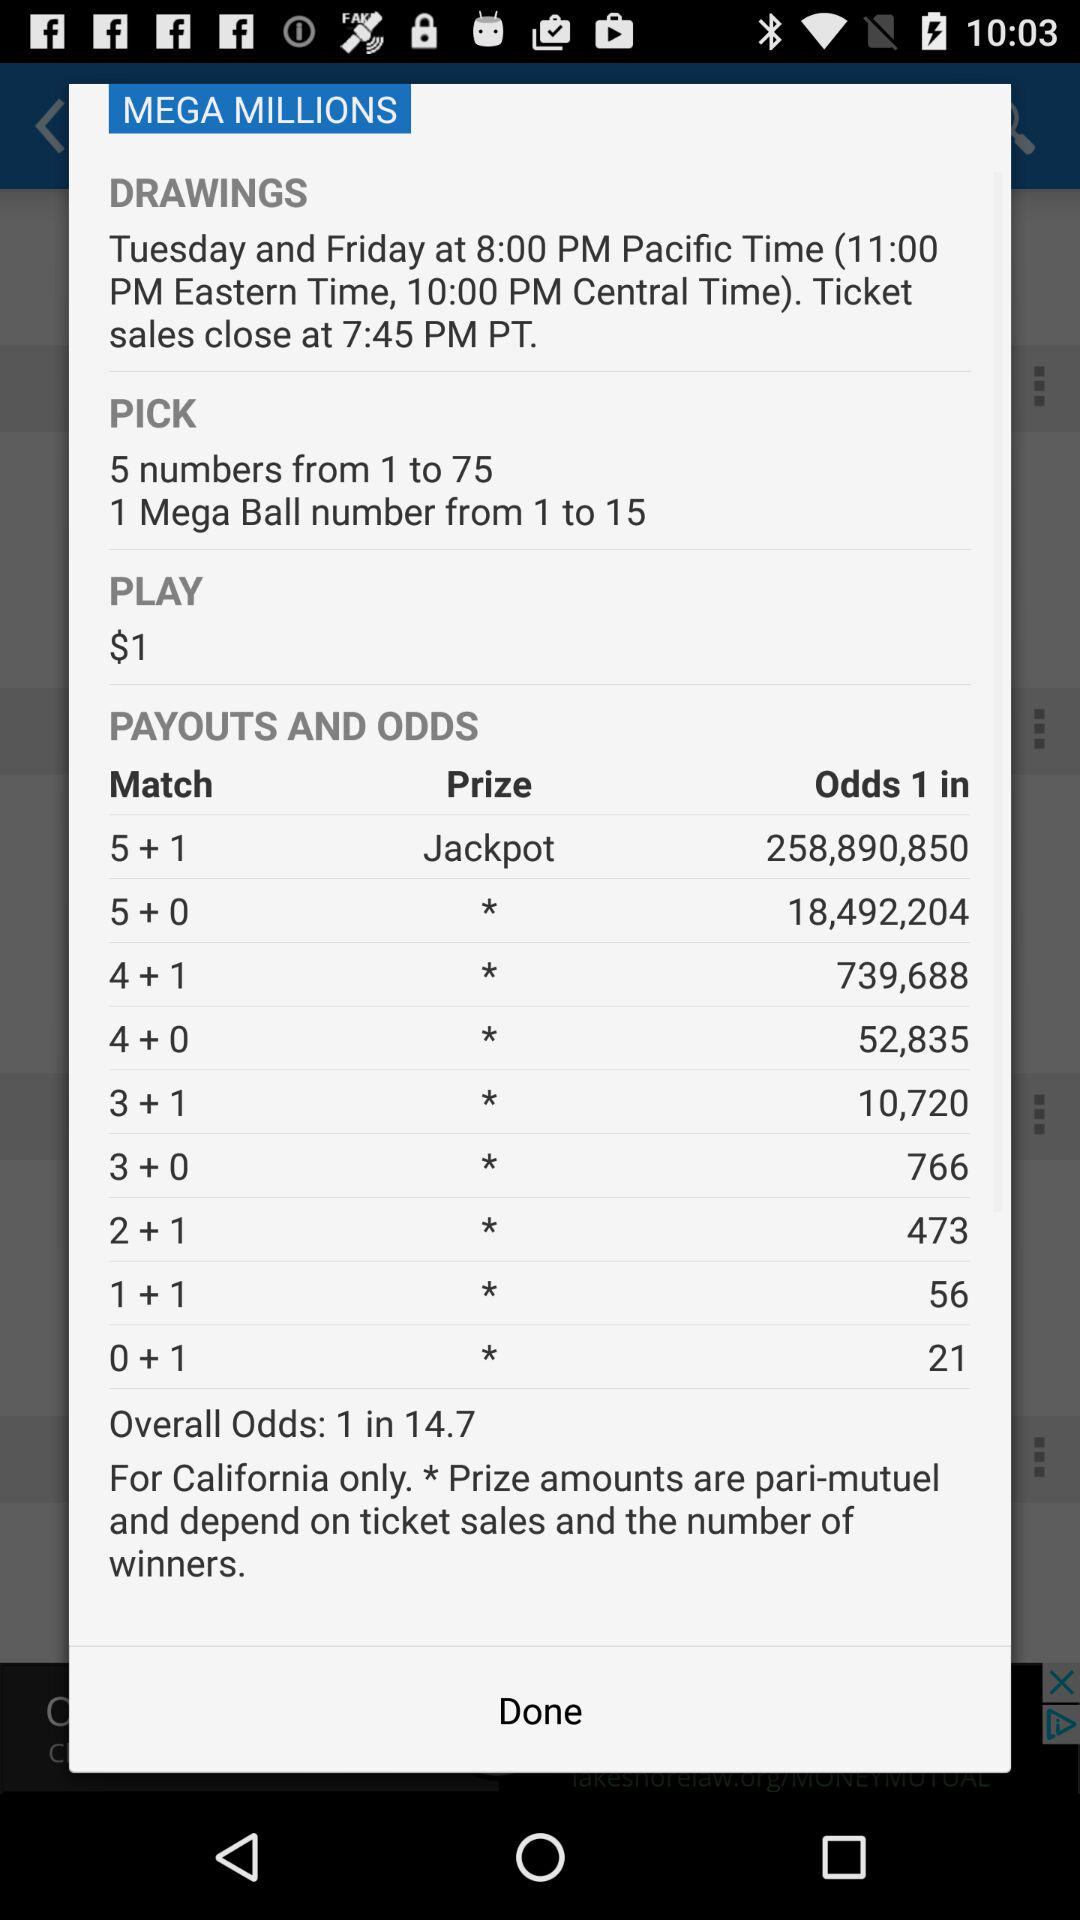When will the ticket sales close? The ticket sales will close at 7:45 p.m. PT. 